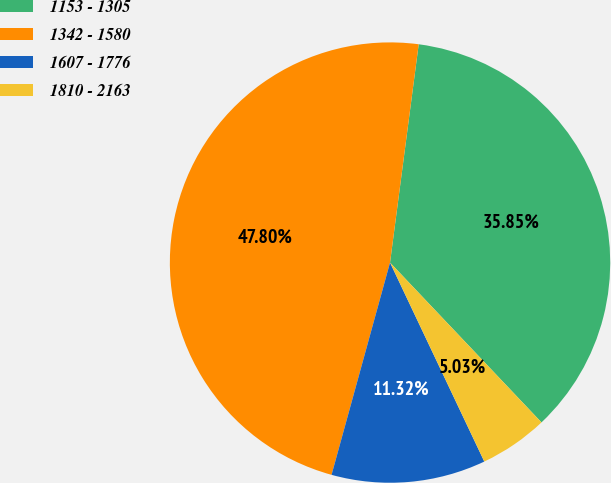Convert chart. <chart><loc_0><loc_0><loc_500><loc_500><pie_chart><fcel>1153 - 1305<fcel>1342 - 1580<fcel>1607 - 1776<fcel>1810 - 2163<nl><fcel>35.85%<fcel>47.8%<fcel>11.32%<fcel>5.03%<nl></chart> 